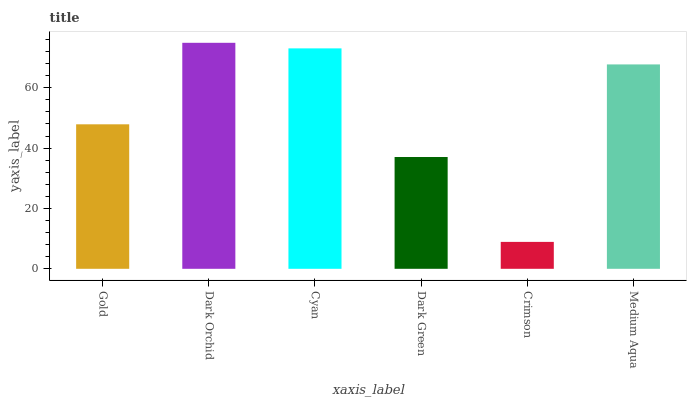Is Crimson the minimum?
Answer yes or no. Yes. Is Dark Orchid the maximum?
Answer yes or no. Yes. Is Cyan the minimum?
Answer yes or no. No. Is Cyan the maximum?
Answer yes or no. No. Is Dark Orchid greater than Cyan?
Answer yes or no. Yes. Is Cyan less than Dark Orchid?
Answer yes or no. Yes. Is Cyan greater than Dark Orchid?
Answer yes or no. No. Is Dark Orchid less than Cyan?
Answer yes or no. No. Is Medium Aqua the high median?
Answer yes or no. Yes. Is Gold the low median?
Answer yes or no. Yes. Is Dark Green the high median?
Answer yes or no. No. Is Dark Orchid the low median?
Answer yes or no. No. 